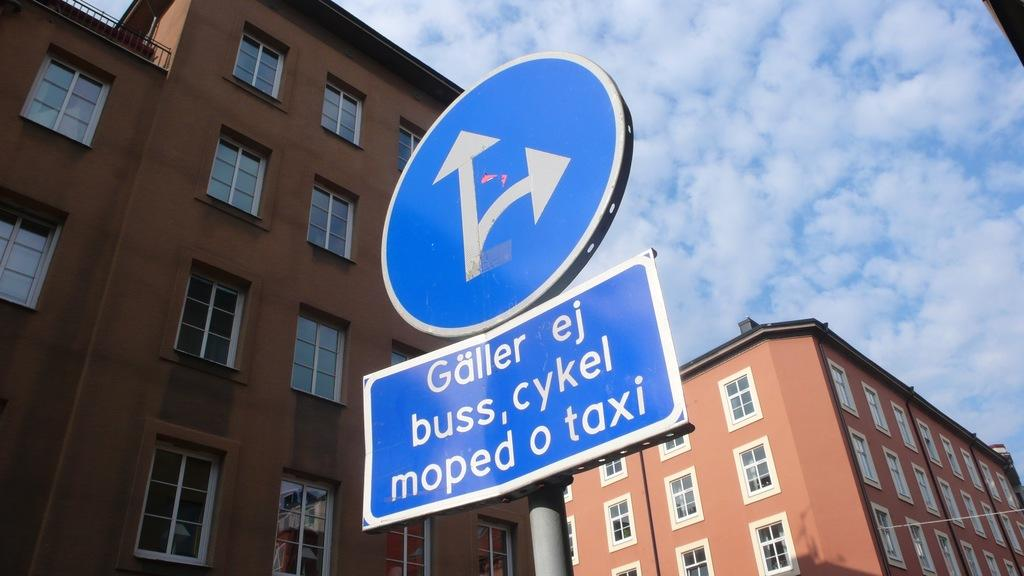What type of objects can be seen in the image that are blue in color? There are two blue color boards in the image. How are the blue color boards positioned in the image? The boards are fixed to a pole. What type of structures can be seen in the image? There are two buildings in the image. What architectural feature can be seen on the buildings? Windows are visible in the image. What is visible in the background of the image? There is a sky with clouds in the background of the image. What type of metal can be seen in the image, such as copper or zinc? There is no mention of copper or zinc in the image; the focus is on the blue color boards, buildings, windows, and the sky with clouds. 